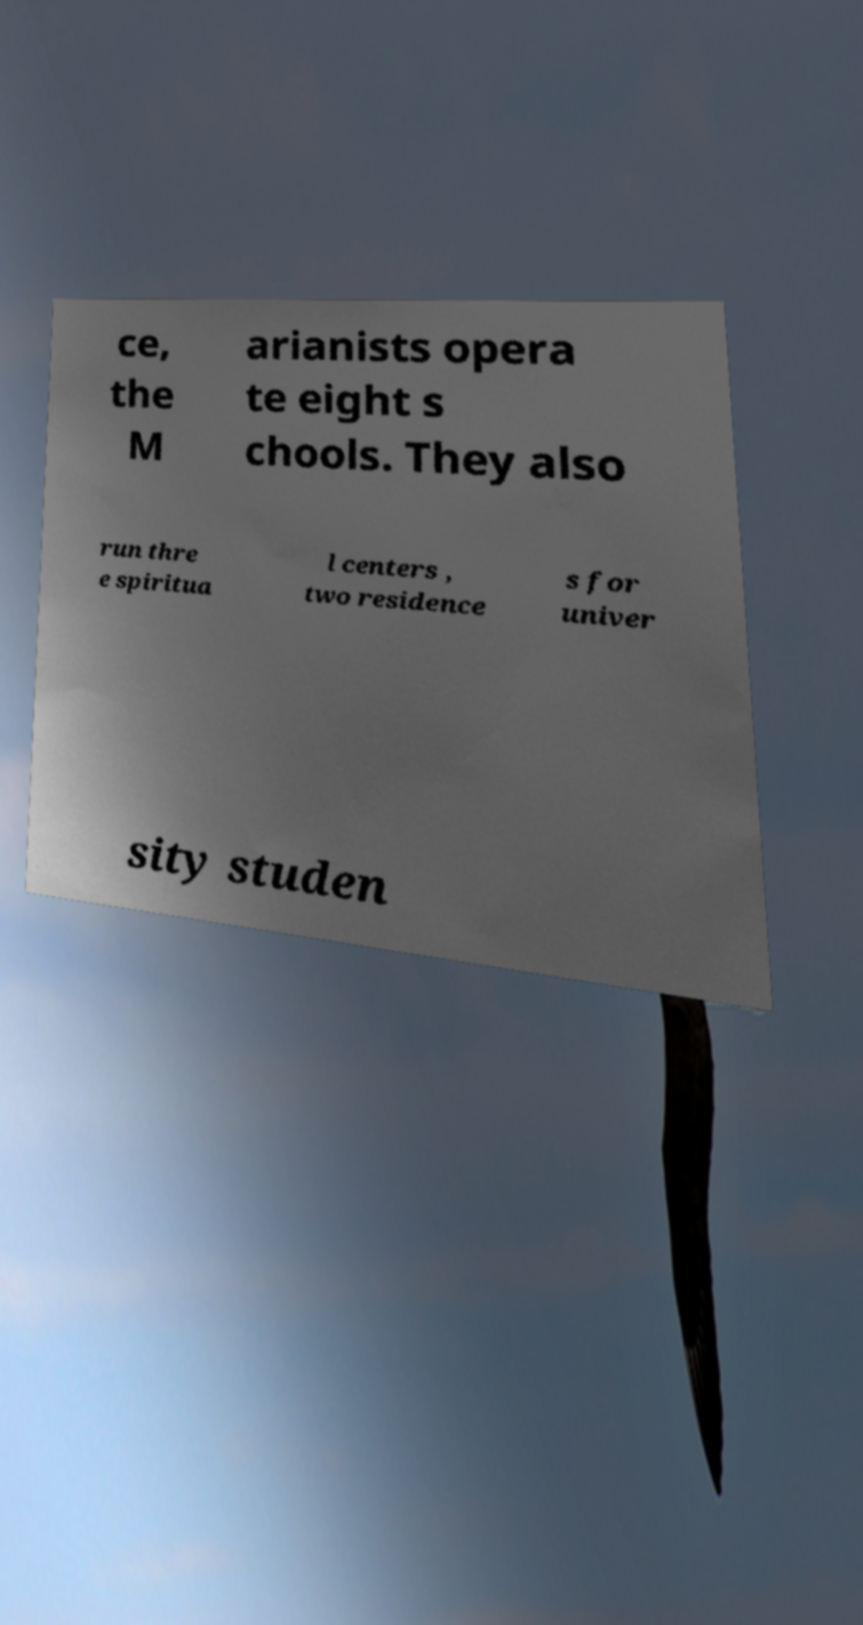Can you accurately transcribe the text from the provided image for me? ce, the M arianists opera te eight s chools. They also run thre e spiritua l centers , two residence s for univer sity studen 